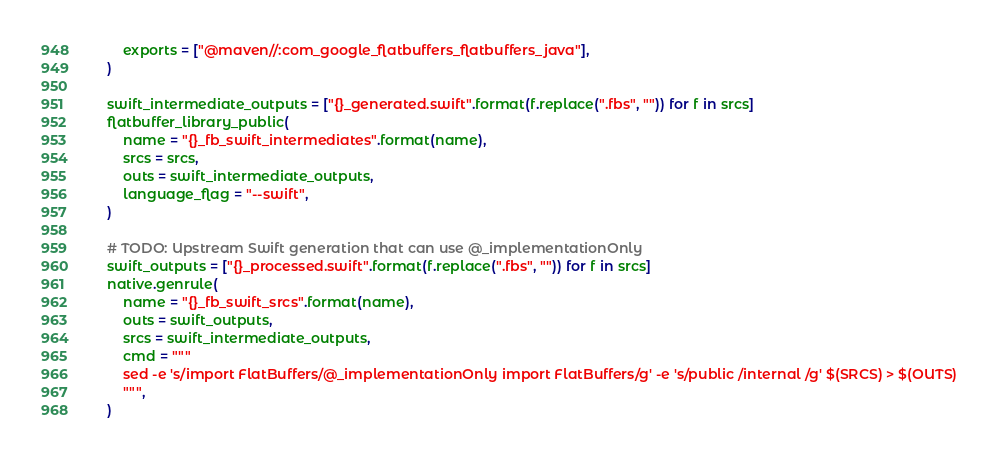<code> <loc_0><loc_0><loc_500><loc_500><_Python_>        exports = ["@maven//:com_google_flatbuffers_flatbuffers_java"],
    )

    swift_intermediate_outputs = ["{}_generated.swift".format(f.replace(".fbs", "")) for f in srcs]
    flatbuffer_library_public(
        name = "{}_fb_swift_intermediates".format(name),
        srcs = srcs,
        outs = swift_intermediate_outputs,
        language_flag = "--swift",
    )

    # TODO: Upstream Swift generation that can use @_implementationOnly
    swift_outputs = ["{}_processed.swift".format(f.replace(".fbs", "")) for f in srcs]
    native.genrule(
        name = "{}_fb_swift_srcs".format(name),
        outs = swift_outputs,
        srcs = swift_intermediate_outputs,
        cmd = """
        sed -e 's/import FlatBuffers/@_implementationOnly import FlatBuffers/g' -e 's/public /internal /g' $(SRCS) > $(OUTS)
        """,
    )
</code> 